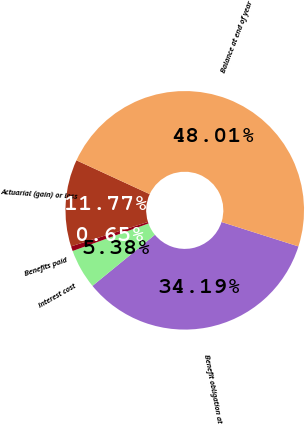<chart> <loc_0><loc_0><loc_500><loc_500><pie_chart><fcel>Benefit obligation at<fcel>Interest cost<fcel>Benefits paid<fcel>Actuarial (gain) or loss<fcel>Balance at end of year<nl><fcel>34.19%<fcel>5.38%<fcel>0.65%<fcel>11.77%<fcel>48.01%<nl></chart> 